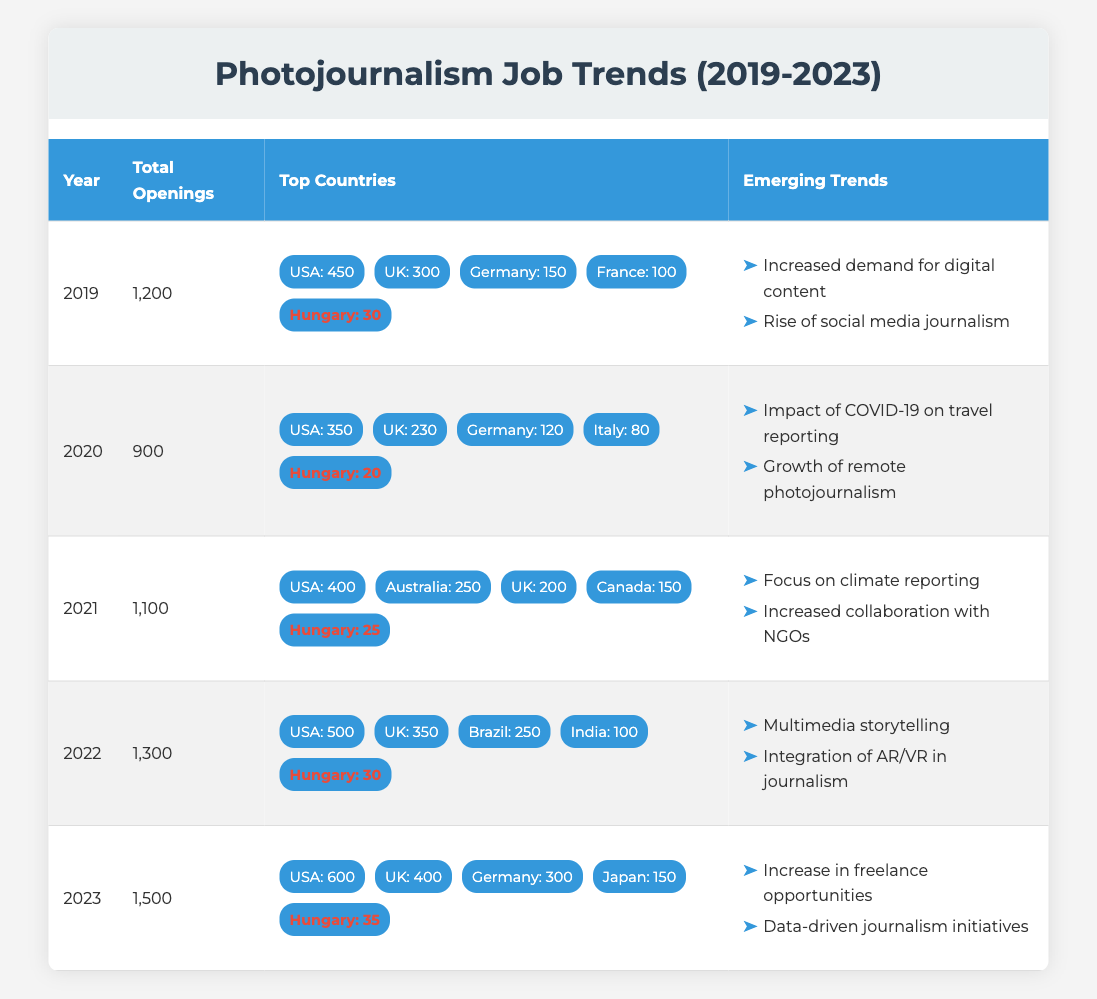What was the total number of photojournalism job openings in 2020? In the table, under the year 2020, the value for total openings is listed directly. The total number of job openings in that year is 900.
Answer: 900 Which country had the highest number of job openings for photojournalists in 2021? Looking under the year 2021, I can see the top country listed is the USA with 400 job openings, which is higher than any other country in that year.
Answer: USA How many job openings for photojournalists were there in Hungary in 2022? In the table for the year 2022, Hungary is highlighted with a specific number of job openings listed as 30.
Answer: 30 What is the average number of job openings for photojournalism from 2019 to 2023? To find the average, I need to add total openings for each year (1200 + 900 + 1100 + 1300 + 1500 = 5000) and divide by the number of years (5). Thus, the average is 5000 / 5 = 1000.
Answer: 1000 Did the number of job openings in the UK increase from 2019 to 2023? I compare the UK job openings in 2019 (300) and in 2023 (400). Since 400 is greater than 300, the number of job openings indeed increased over these years.
Answer: Yes Which year had the most significant increase in total job openings compared to the previous year? By analyzing the total openings from year to year: 2019 to 2020 is a decrease of 300, 2020 to 2021 is an increase of 200, 2021 to 2022 is an increase of 200, and 2022 to 2023 is an increase of 200 as well. The largest increase or decrease is 200, but no significant drop occurred after 2019.
Answer: 2021 to 2022 Was there a decline in total job openings from 2019 to 2020? The total openings decreased from 1200 in 2019 to 900 in 2020, confirming there was a decline in job openings during this period.
Answer: Yes What are two emerging trends in photojournalism from 2023? In the 2023 row, two trends are listed: "Increase in freelance opportunities" and "Data-driven journalism initiatives" as current themes in the field.
Answer: Increase in freelance opportunities and Data-driven journalism initiatives 